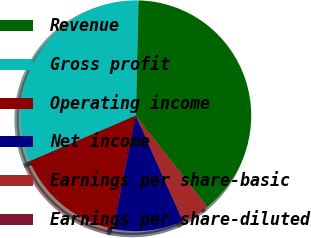Convert chart to OTSL. <chart><loc_0><loc_0><loc_500><loc_500><pie_chart><fcel>Revenue<fcel>Gross profit<fcel>Operating income<fcel>Net income<fcel>Earnings per share-basic<fcel>Earnings per share-diluted<nl><fcel>39.02%<fcel>31.82%<fcel>15.38%<fcel>9.87%<fcel>3.9%<fcel>0.0%<nl></chart> 